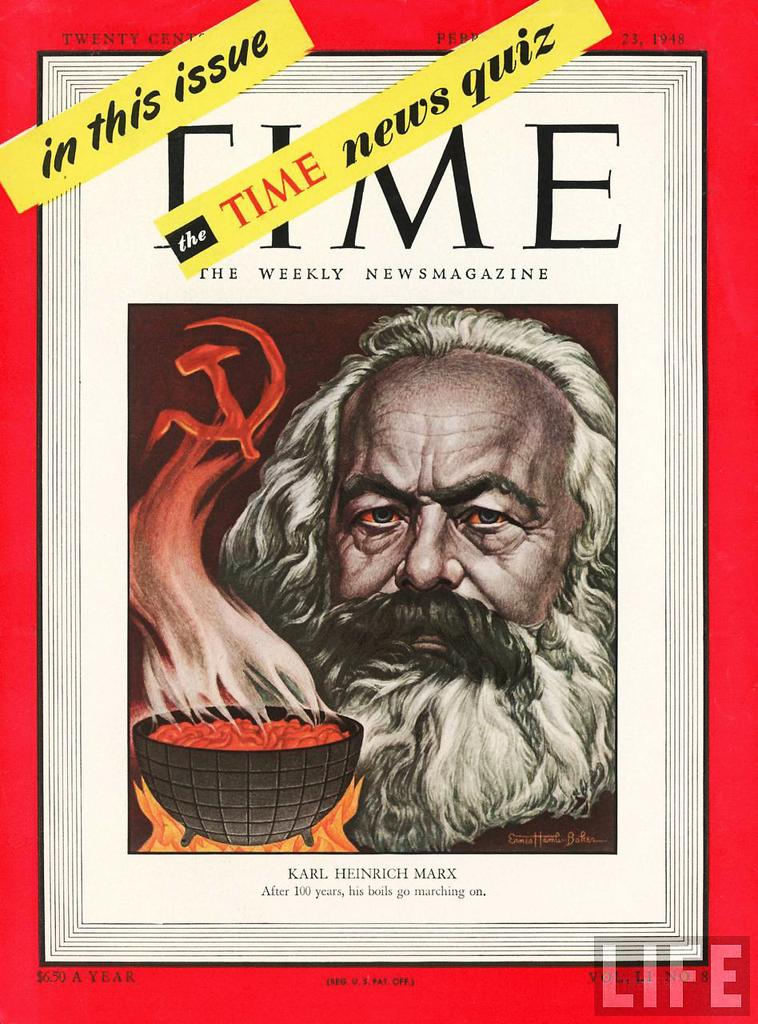<image>
Offer a succinct explanation of the picture presented. copy of time magazine by karl henrich mark 